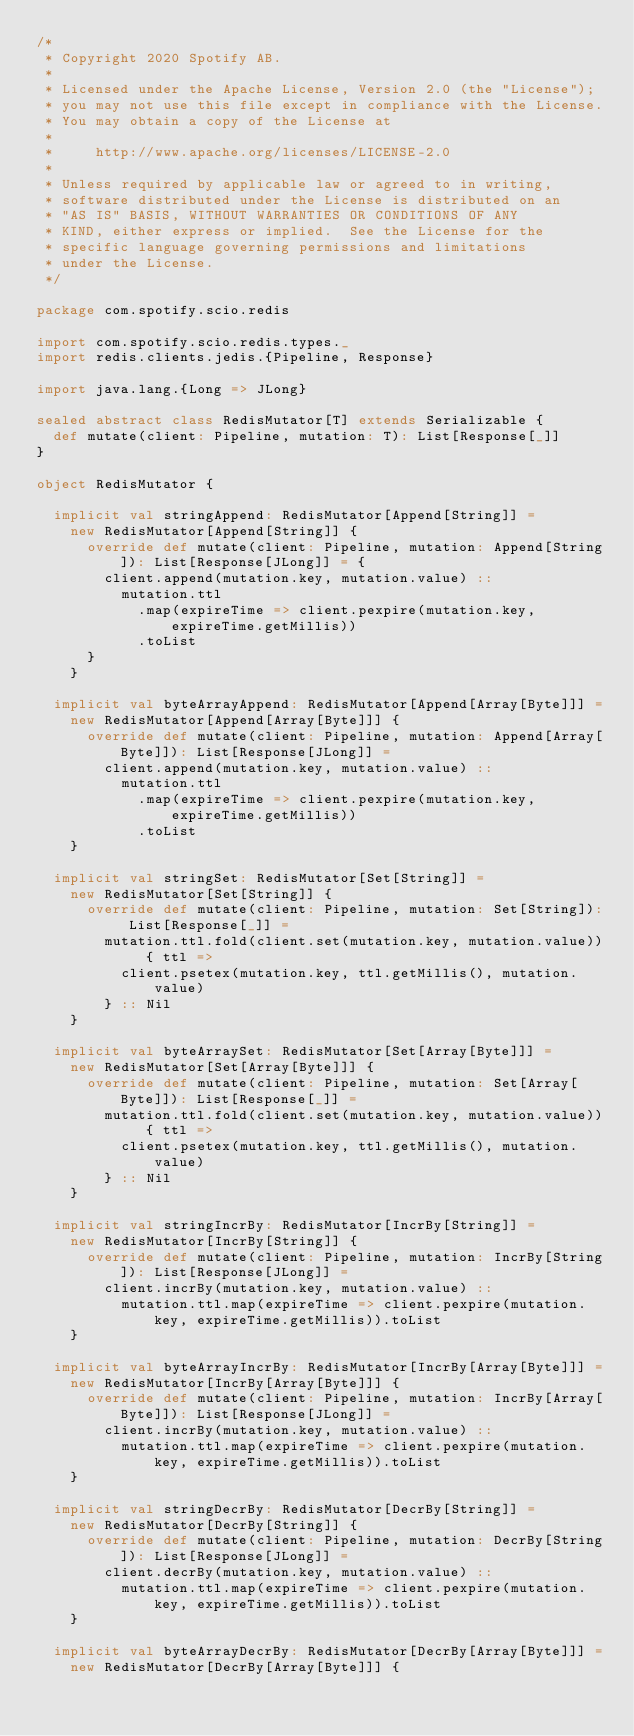Convert code to text. <code><loc_0><loc_0><loc_500><loc_500><_Scala_>/*
 * Copyright 2020 Spotify AB.
 *
 * Licensed under the Apache License, Version 2.0 (the "License");
 * you may not use this file except in compliance with the License.
 * You may obtain a copy of the License at
 *
 *     http://www.apache.org/licenses/LICENSE-2.0
 *
 * Unless required by applicable law or agreed to in writing,
 * software distributed under the License is distributed on an
 * "AS IS" BASIS, WITHOUT WARRANTIES OR CONDITIONS OF ANY
 * KIND, either express or implied.  See the License for the
 * specific language governing permissions and limitations
 * under the License.
 */

package com.spotify.scio.redis

import com.spotify.scio.redis.types._
import redis.clients.jedis.{Pipeline, Response}

import java.lang.{Long => JLong}

sealed abstract class RedisMutator[T] extends Serializable {
  def mutate(client: Pipeline, mutation: T): List[Response[_]]
}

object RedisMutator {

  implicit val stringAppend: RedisMutator[Append[String]] =
    new RedisMutator[Append[String]] {
      override def mutate(client: Pipeline, mutation: Append[String]): List[Response[JLong]] = {
        client.append(mutation.key, mutation.value) ::
          mutation.ttl
            .map(expireTime => client.pexpire(mutation.key, expireTime.getMillis))
            .toList
      }
    }

  implicit val byteArrayAppend: RedisMutator[Append[Array[Byte]]] =
    new RedisMutator[Append[Array[Byte]]] {
      override def mutate(client: Pipeline, mutation: Append[Array[Byte]]): List[Response[JLong]] =
        client.append(mutation.key, mutation.value) ::
          mutation.ttl
            .map(expireTime => client.pexpire(mutation.key, expireTime.getMillis))
            .toList
    }

  implicit val stringSet: RedisMutator[Set[String]] =
    new RedisMutator[Set[String]] {
      override def mutate(client: Pipeline, mutation: Set[String]): List[Response[_]] =
        mutation.ttl.fold(client.set(mutation.key, mutation.value)) { ttl =>
          client.psetex(mutation.key, ttl.getMillis(), mutation.value)
        } :: Nil
    }

  implicit val byteArraySet: RedisMutator[Set[Array[Byte]]] =
    new RedisMutator[Set[Array[Byte]]] {
      override def mutate(client: Pipeline, mutation: Set[Array[Byte]]): List[Response[_]] =
        mutation.ttl.fold(client.set(mutation.key, mutation.value)) { ttl =>
          client.psetex(mutation.key, ttl.getMillis(), mutation.value)
        } :: Nil
    }

  implicit val stringIncrBy: RedisMutator[IncrBy[String]] =
    new RedisMutator[IncrBy[String]] {
      override def mutate(client: Pipeline, mutation: IncrBy[String]): List[Response[JLong]] =
        client.incrBy(mutation.key, mutation.value) ::
          mutation.ttl.map(expireTime => client.pexpire(mutation.key, expireTime.getMillis)).toList
    }

  implicit val byteArrayIncrBy: RedisMutator[IncrBy[Array[Byte]]] =
    new RedisMutator[IncrBy[Array[Byte]]] {
      override def mutate(client: Pipeline, mutation: IncrBy[Array[Byte]]): List[Response[JLong]] =
        client.incrBy(mutation.key, mutation.value) ::
          mutation.ttl.map(expireTime => client.pexpire(mutation.key, expireTime.getMillis)).toList
    }

  implicit val stringDecrBy: RedisMutator[DecrBy[String]] =
    new RedisMutator[DecrBy[String]] {
      override def mutate(client: Pipeline, mutation: DecrBy[String]): List[Response[JLong]] =
        client.decrBy(mutation.key, mutation.value) ::
          mutation.ttl.map(expireTime => client.pexpire(mutation.key, expireTime.getMillis)).toList
    }

  implicit val byteArrayDecrBy: RedisMutator[DecrBy[Array[Byte]]] =
    new RedisMutator[DecrBy[Array[Byte]]] {</code> 